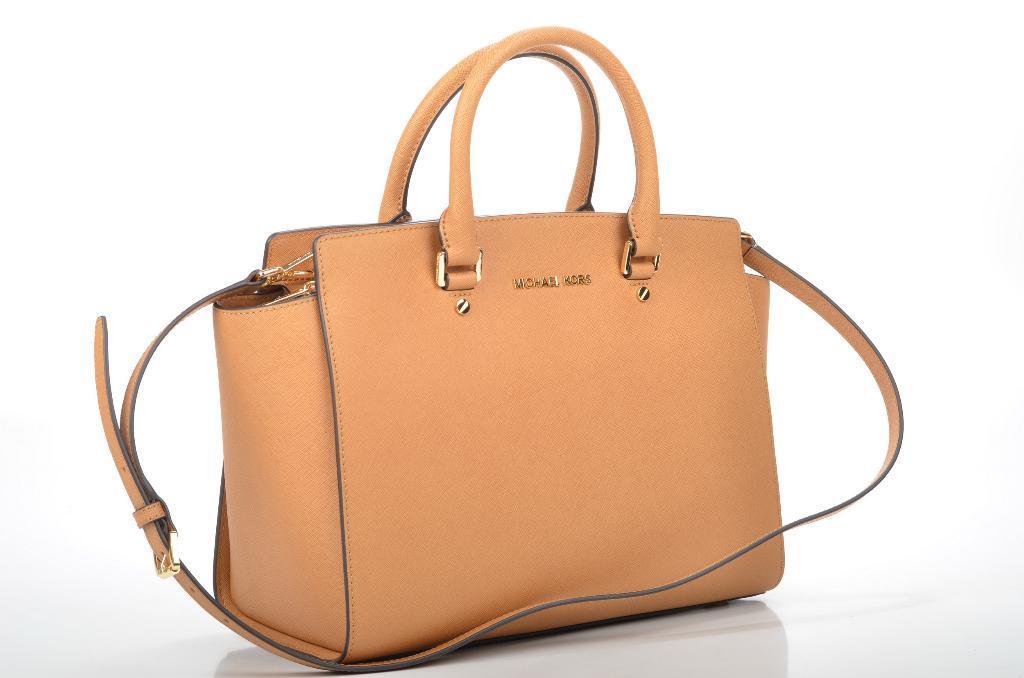Please provide a concise description of this image. There is one bag present in the picture it is in orange colour from Michael kors. 